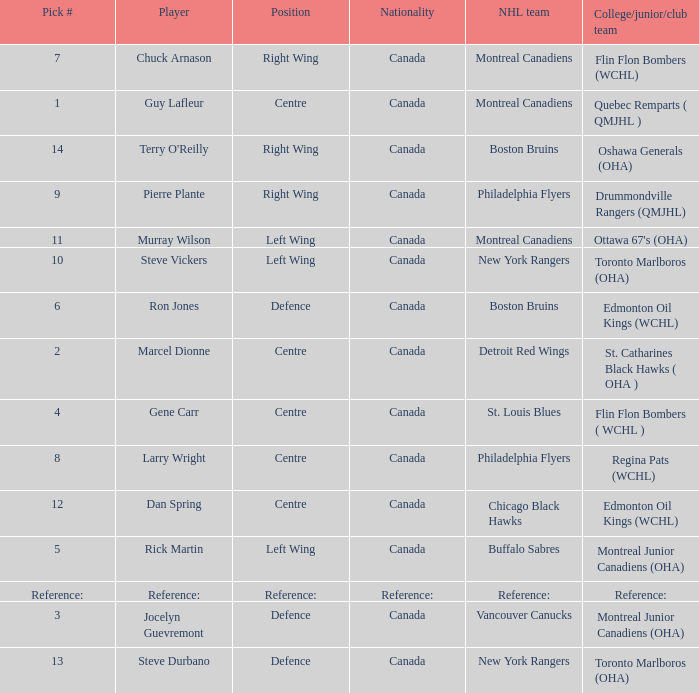Which Pick # has an NHL team of detroit red wings? 2.0. 